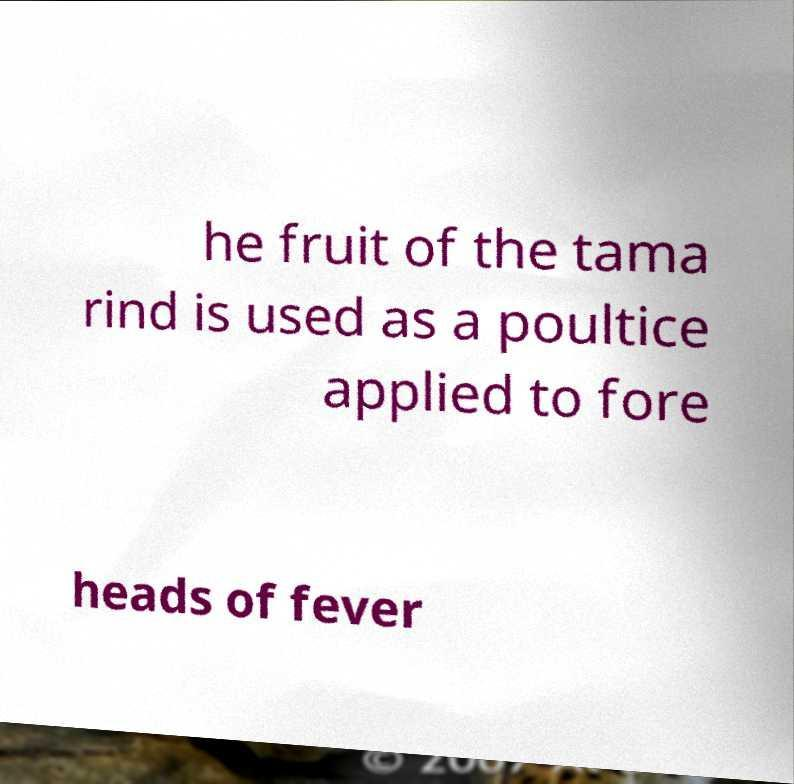Can you accurately transcribe the text from the provided image for me? he fruit of the tama rind is used as a poultice applied to fore heads of fever 